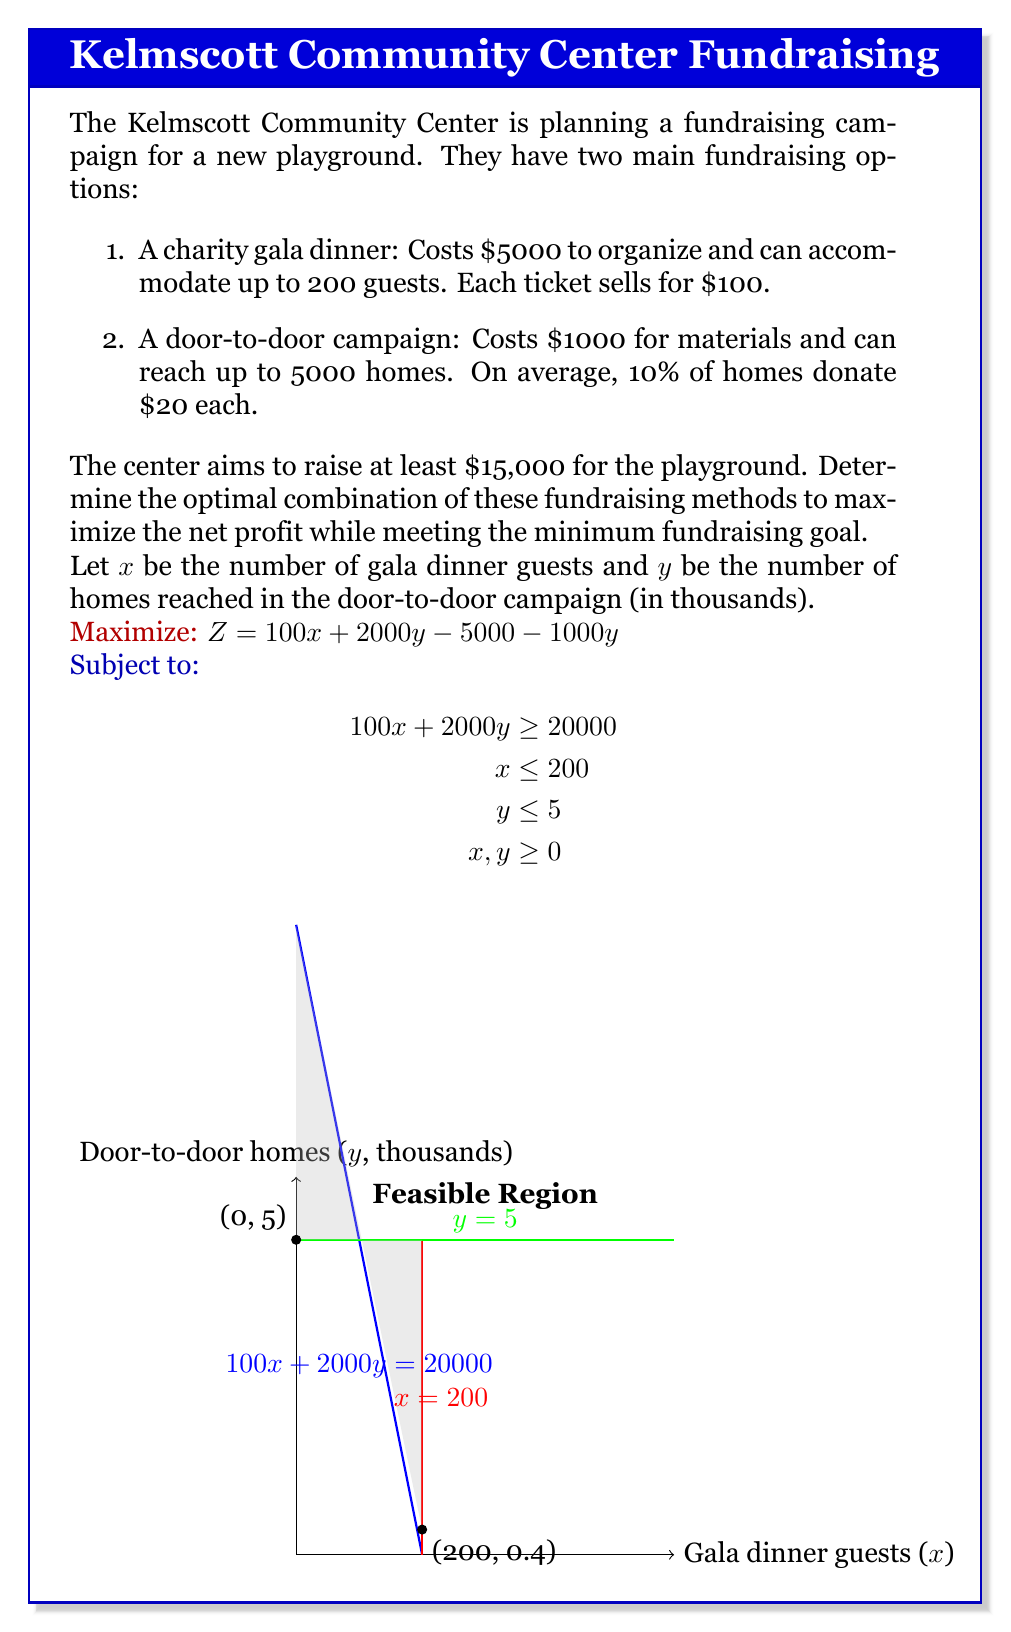Can you solve this math problem? To solve this linear programming problem, we'll follow these steps:

1) Identify the feasible region:
   The constraints form a polygon in the first quadrant, bounded by:
   - $100x + 2000y = 20000$ (minimum fundraising goal)
   - $x = 200$ (maximum gala capacity)
   - $y = 5$ (maximum homes for door-to-door)
   - $x, y \geq 0$ (non-negativity)

2) Find the vertices of the feasible region:
   A: (0, 10) - intersection of $100x + 2000y = 20000$ and y-axis
   B: (200, 0.4) - intersection of $100x + 2000y = 20000$ and $x = 200$
   C: (200, 5) - intersection of $x = 200$ and $y = 5$
   D: (0, 5) - intersection of $y = 5$ and y-axis

3) Evaluate the objective function at each vertex:
   $Z = 100x + 1000y - 5000$
   
   A (0, 10):   $Z = 0 + 1000(10) - 5000 = 5000$
   B (200, 0.4): $Z = 20000 + 1000(0.4) - 5000 = 15400$
   C (200, 5):   $Z = 20000 + 1000(5) - 5000 = 20000$
   D (0, 5):    $Z = 0 + 1000(5) - 5000 = 0$

4) The maximum value occurs at vertex C (200, 5), which represents:
   - 200 guests at the gala dinner
   - Reaching 5000 homes in the door-to-door campaign

5) Calculate the total funds raised:
   Gala dinner: $200 \times $100 = $20,000
   Door-to-door: $5000 \times 10\% \times $20 = $10,000
   Total: $30,000

6) Calculate the net profit:
   Total funds - Costs = $30,000 - ($5000 + $1000) = $24,000

Therefore, the optimal strategy is to hold the gala dinner at full capacity and conduct the door-to-door campaign to its maximum reach.
Answer: Hold a full-capacity gala dinner (200 guests) and conduct a maximum-reach door-to-door campaign (5000 homes). Net profit: $24,000. 